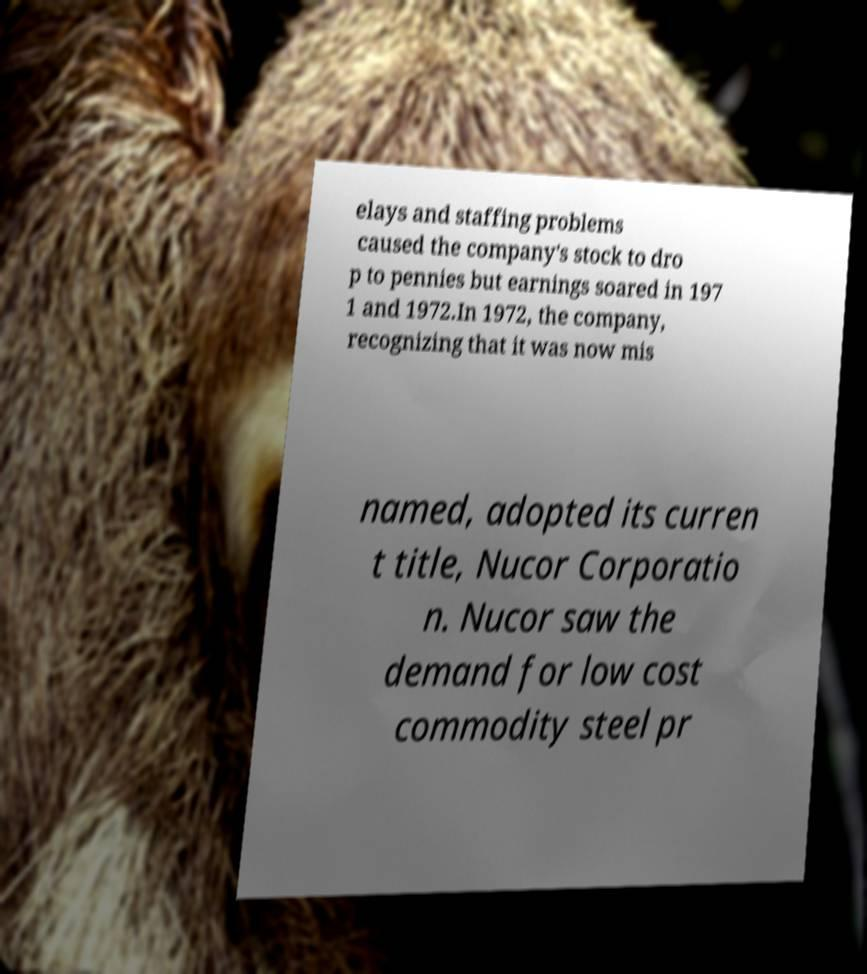Please read and relay the text visible in this image. What does it say? elays and staffing problems caused the company's stock to dro p to pennies but earnings soared in 197 1 and 1972.In 1972, the company, recognizing that it was now mis named, adopted its curren t title, Nucor Corporatio n. Nucor saw the demand for low cost commodity steel pr 